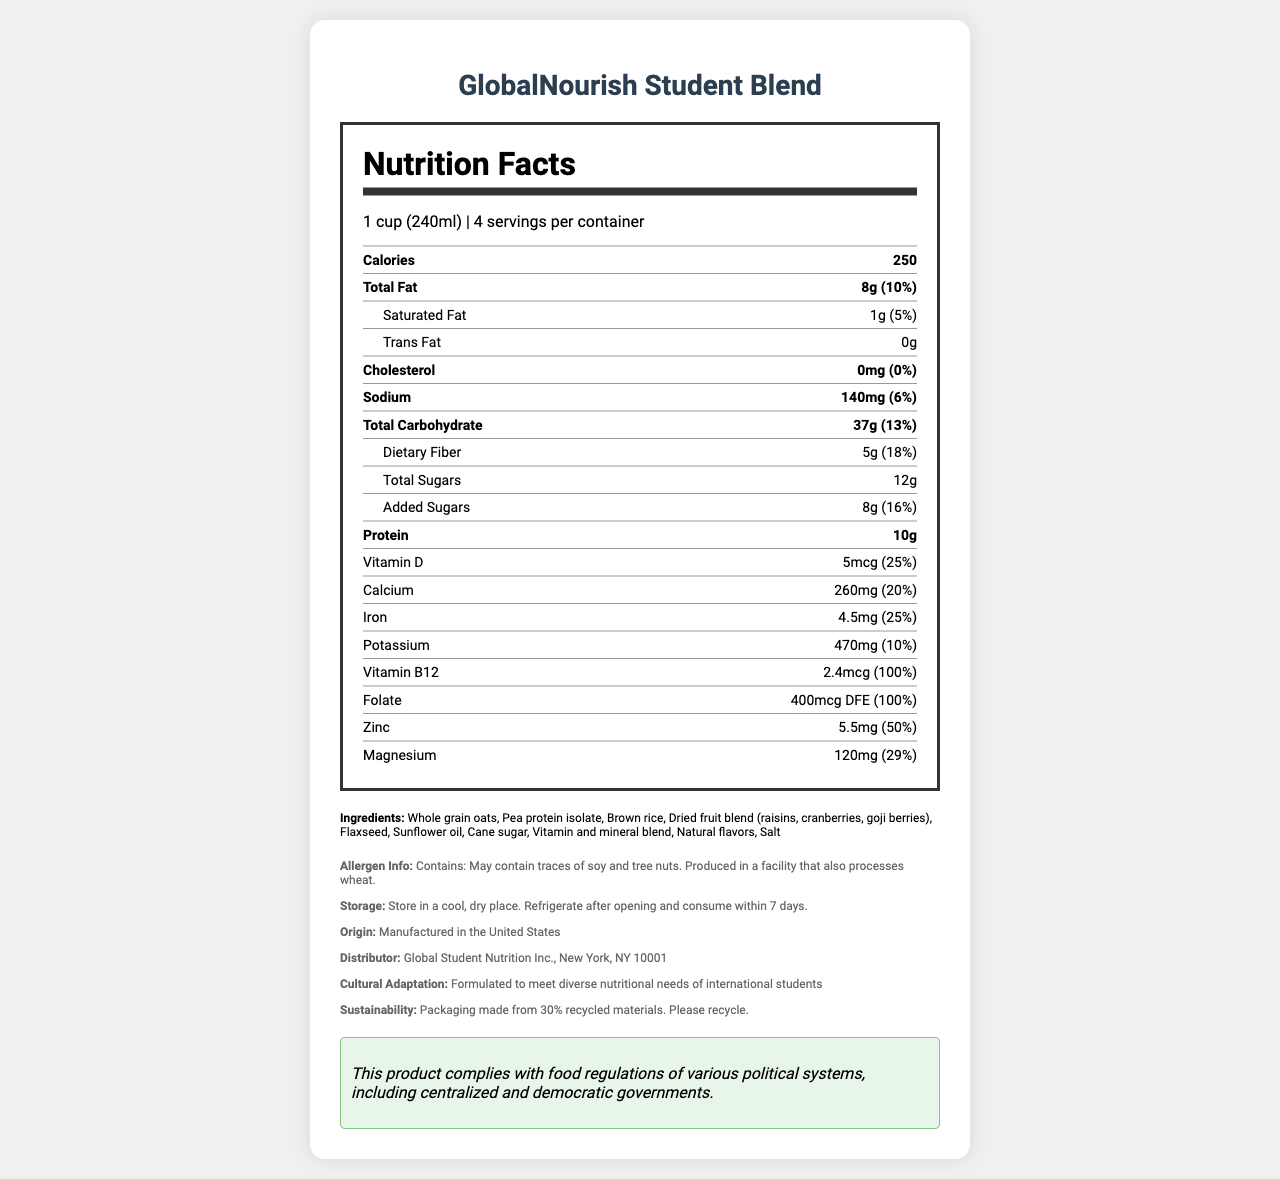what is the serving size of GlobalNourish Student Blend? The serving size is stated at the beginning of the nutrition label as "1 cup (240ml)".
Answer: 1 cup (240ml) how many servings are there per container? The document mentions "4 servings per container" right after the serving size information.
Answer: 4 servings what is the amount of protein per serving? The amount of protein is explicitly listed as 10g under the nutrition facts.
Answer: 10g List three key vitamins and minerals found in GlobalNourish Student Blend. The vitamins and minerals such as Vitamin D, Calcium, Iron are highlighted in the document under the nutrition facts section.
Answer: Vitamin D, Calcium, Iron what are the ingredients of the GlobalNourish Student Blend? The ingredients are listed after the nutrition facts under the "Ingredients" section.
Answer: Whole grain oats, Pea protein isolate, Brown rice, Dried fruit blend (raisins, cranberries, goji berries), Flaxseed, Sunflower oil, Cane sugar, Vitamin and mineral blend, Natural flavors, Salt How much dietary fiber is in a single serving? The amount of dietary fiber per serving is listed as 5g in the nutrition facts.
Answer: 5g Who is the distributor of the product? The distributor information is provided in the info section of the document.
Answer: Global Student Nutrition Inc., New York, NY 10001 Does the product contain any trans fats? The nutrition label specifies "Trans Fat 0g", indicating there are no trans fats.
Answer: No Does the GlobalNourish Student Blend contain any potential allergens? The allergen information states that it may contain traces of soy and tree nuts and is produced in a facility that also processes wheat.
Answer: Yes what is the percentage daily value of added sugars in this product? The document shows that the percentage daily value (%DV) for added sugars is 16%.
Answer: 16% Which of the following is NOT an ingredient in this product?
A. Whole grain oats 
B. Cane sugar 
C. Soy protein isolate The actual ingredient is "Pea protein isolate" and not "Soy protein isolate".
Answer: C What is the daily value percentage for Vitamin B12?
I. 25% 
II. 50% 
III. 100% According to the nutrition label, the percentage daily value for Vitamin B12 is 100%.
Answer: III Is this product designed with cultural adaptation for international students? The document explicitly states that the product is formulated to meet the diverse nutritional needs of international students.
Answer: Yes Summarize the document in a couple of sentences. This summary captures the essential points covered in the document, including nutritional content, ingredients, allergen information, and additional notes.
Answer: The document details the nutrition facts, ingredients, and other relevant information for the GlobalNourish Student Blend, a nutrient-fortified food product designed for international students. It includes specifics on serving size, vitamins, minerals, and allergen information, along with notes on cultural adaptation, sustainability, and compliance with food regulations. Where is the GlobalNourish Student Blend manufactured? The country of origin is mentioned as "Manufactured in the United States" in the info section.
Answer: Manufactured in the United States How many grams of total carbohydrates are in a single serving? The amount of total carbohydrates per serving is listed as 37g in the nutrition facts.
Answer: 37g What is the political system of the distributor’s country? The document does not provide information about the political system of the United States or any other political details related to the distributor.
Answer: Cannot be determined 